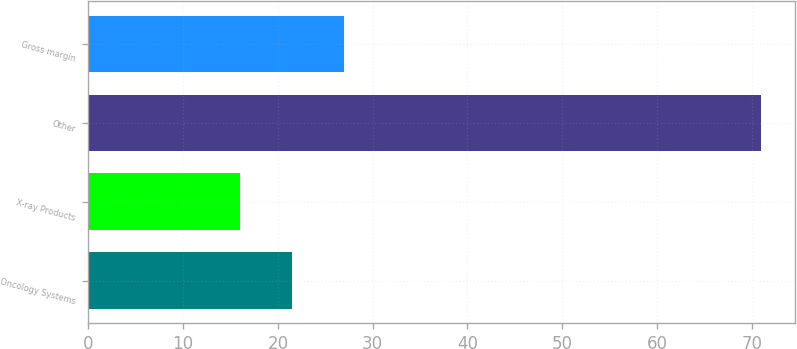Convert chart. <chart><loc_0><loc_0><loc_500><loc_500><bar_chart><fcel>Oncology Systems<fcel>X-ray Products<fcel>Other<fcel>Gross margin<nl><fcel>21.5<fcel>16<fcel>71<fcel>27<nl></chart> 